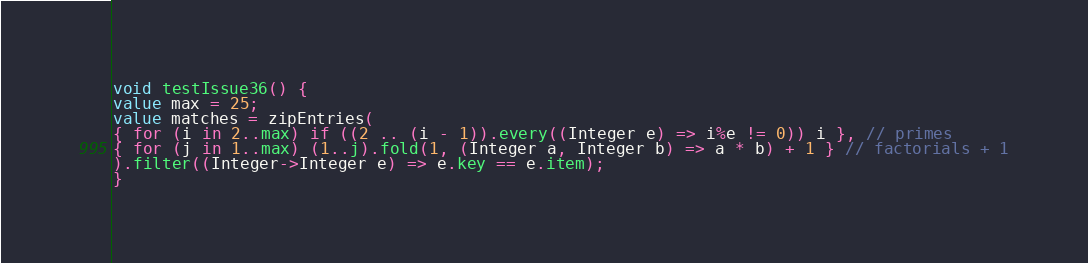<code> <loc_0><loc_0><loc_500><loc_500><_Ceylon_>void testIssue36() {
value max = 25;
value matches = zipEntries(
{ for (i in 2..max) if ((2 .. (i - 1)).every((Integer e) => i%e != 0)) i }, // primes
{ for (j in 1..max) (1..j).fold(1, (Integer a, Integer b) => a * b) + 1 } // factorials + 1
).filter((Integer->Integer e) => e.key == e.item);
}
</code> 